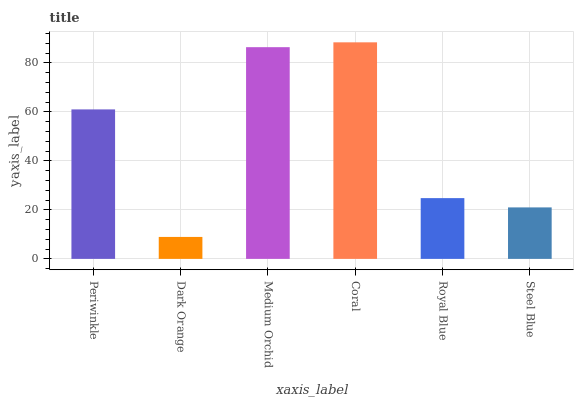Is Dark Orange the minimum?
Answer yes or no. Yes. Is Coral the maximum?
Answer yes or no. Yes. Is Medium Orchid the minimum?
Answer yes or no. No. Is Medium Orchid the maximum?
Answer yes or no. No. Is Medium Orchid greater than Dark Orange?
Answer yes or no. Yes. Is Dark Orange less than Medium Orchid?
Answer yes or no. Yes. Is Dark Orange greater than Medium Orchid?
Answer yes or no. No. Is Medium Orchid less than Dark Orange?
Answer yes or no. No. Is Periwinkle the high median?
Answer yes or no. Yes. Is Royal Blue the low median?
Answer yes or no. Yes. Is Royal Blue the high median?
Answer yes or no. No. Is Medium Orchid the low median?
Answer yes or no. No. 